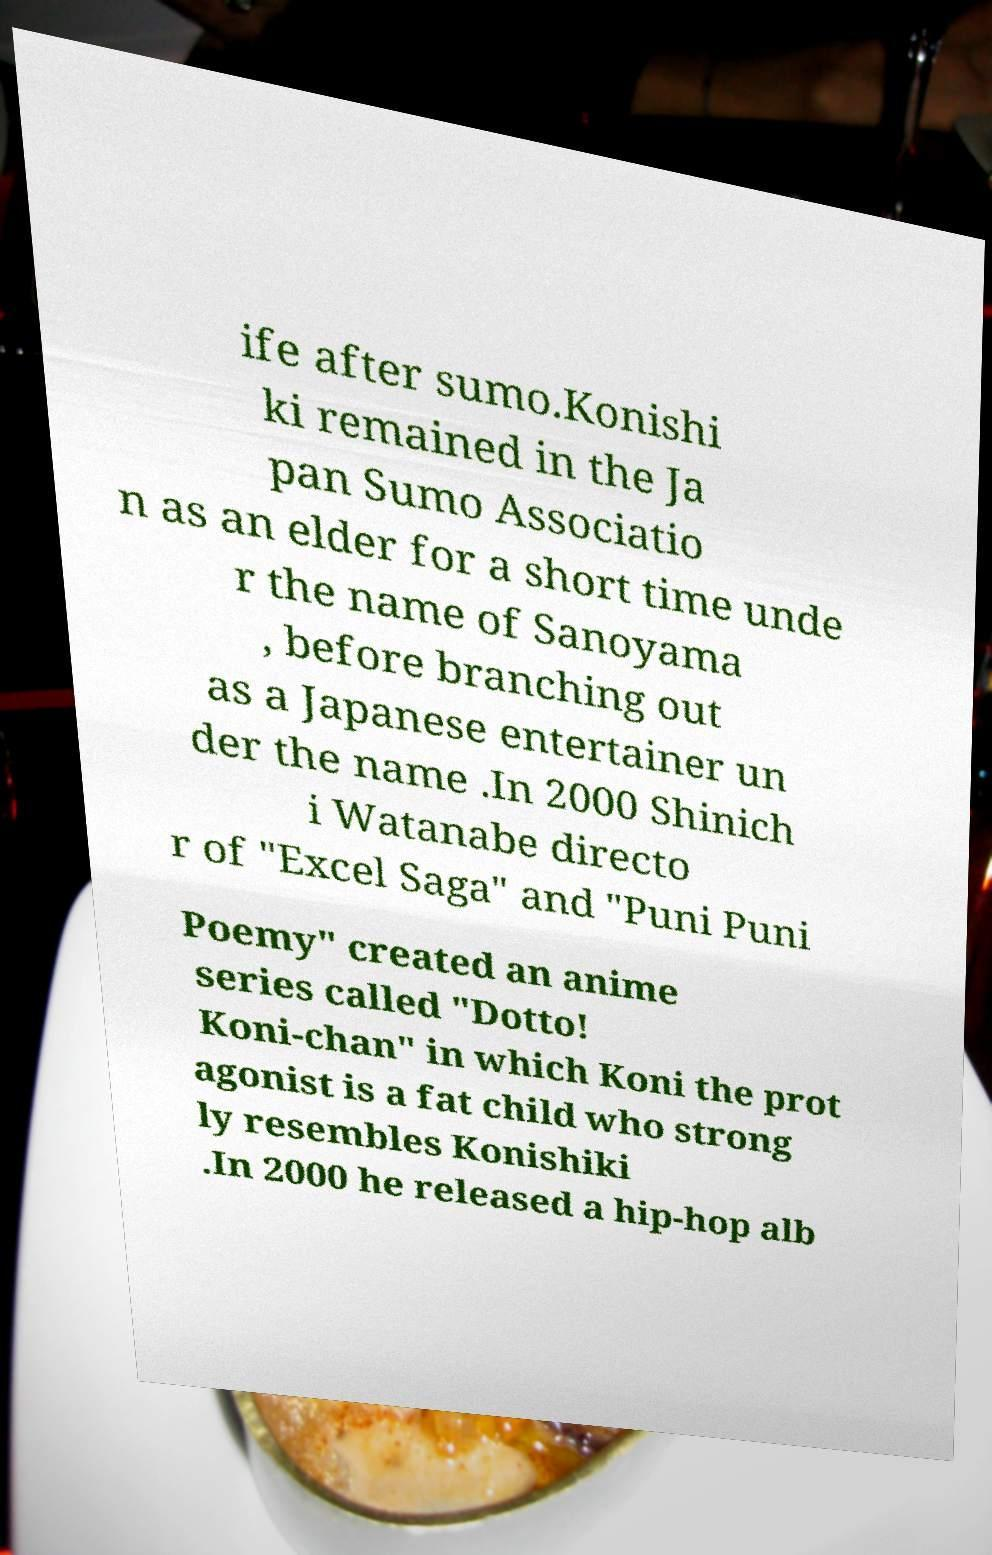Can you read and provide the text displayed in the image?This photo seems to have some interesting text. Can you extract and type it out for me? ife after sumo.Konishi ki remained in the Ja pan Sumo Associatio n as an elder for a short time unde r the name of Sanoyama , before branching out as a Japanese entertainer un der the name .In 2000 Shinich i Watanabe directo r of "Excel Saga" and "Puni Puni Poemy" created an anime series called "Dotto! Koni-chan" in which Koni the prot agonist is a fat child who strong ly resembles Konishiki .In 2000 he released a hip-hop alb 